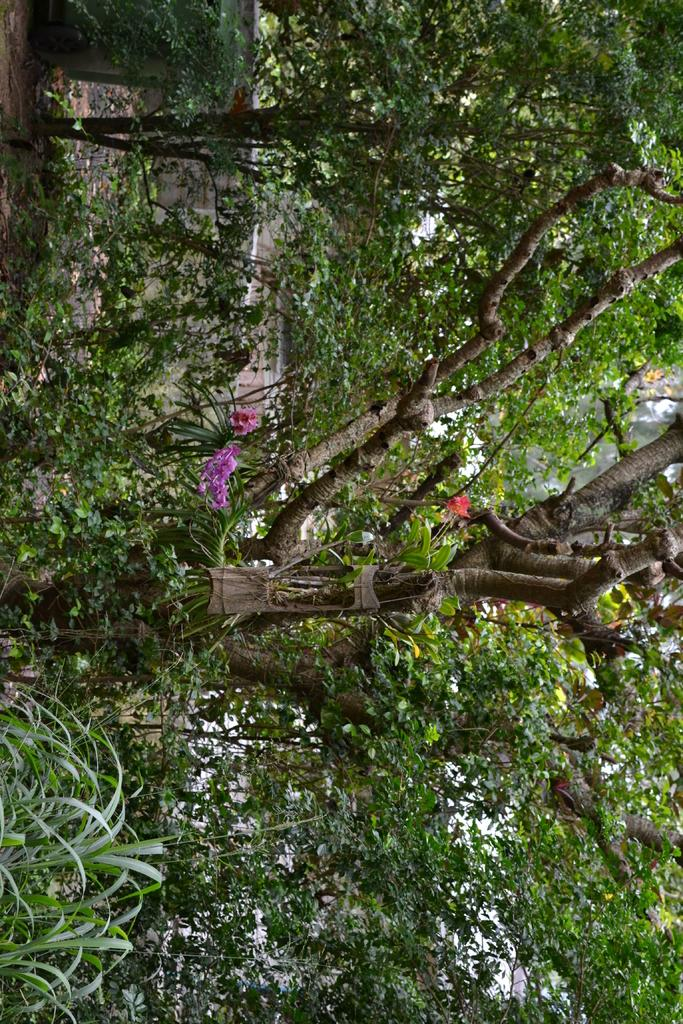What is there are many trees visible in the image. Can you describe their appearance or characteristics? Unfortunately, the provided facts do not give specific details about the appearance or characteristics of the trees. However, we can confirm that there are many trees in the image. How many times does the tongue appear in the image? There is no mention of a tongue in the provided facts, so we cannot answer any questions about its presence or appearance in the image. 